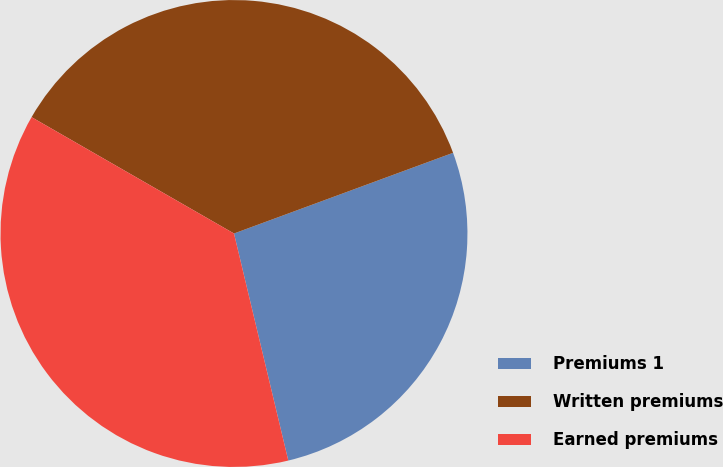<chart> <loc_0><loc_0><loc_500><loc_500><pie_chart><fcel>Premiums 1<fcel>Written premiums<fcel>Earned premiums<nl><fcel>26.88%<fcel>36.08%<fcel>37.04%<nl></chart> 